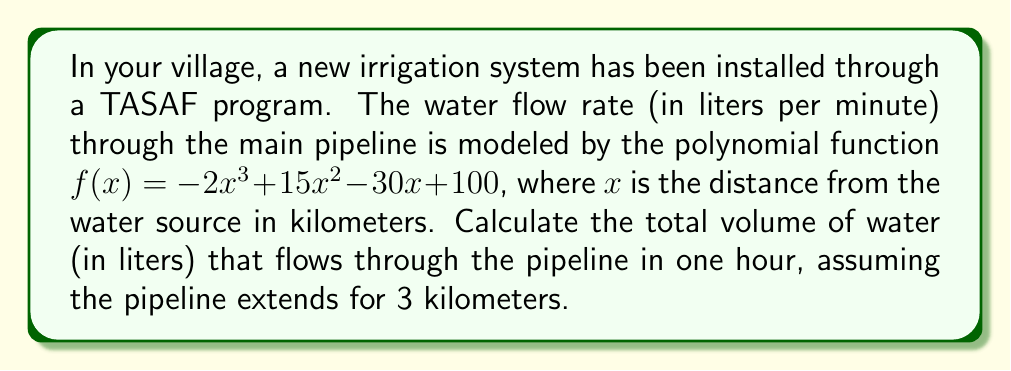Can you answer this question? To solve this problem, we need to follow these steps:

1) First, we need to find the average flow rate over the 3 km length of the pipeline. This can be done by integrating the flow rate function over the distance and dividing by the total distance.

2) The integral of $f(x)$ from 0 to 3 is:

   $$\int_0^3 (-2x^3 + 15x^2 - 30x + 100) dx$$

3) Integrating this polynomial:

   $$[-\frac{1}{2}x^4 + 5x^3 - 15x^2 + 100x]_0^3$$

4) Evaluating at the limits:

   $$(-\frac{1}{2}(3^4) + 5(3^3) - 15(3^2) + 100(3)) - (-\frac{1}{2}(0^4) + 5(0^3) - 15(0^2) + 100(0))$$
   
   $$= (-40.5 + 135 - 135 + 300) - 0 = 259.5$$

5) The average flow rate is this value divided by the total distance:

   $$\frac{259.5}{3} = 86.5$$ liters per minute

6) To find the total volume in one hour, we multiply this by 60 minutes:

   $$86.5 * 60 = 5190$$ liters
Answer: 5190 liters 